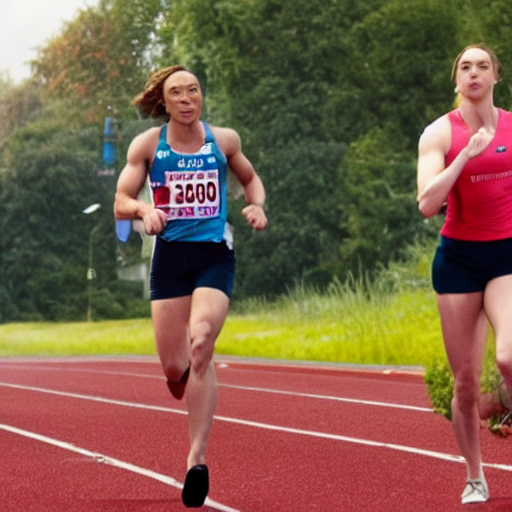Can you describe the expressions and body language of the athletes? The central athlete exhibits a focused and determined expression, with her gaze fixed straight ahead, suggesting she's in a critical moment of competition. Her body language, with powerful strides and arms driving in opposition, indicates she's exerting substantial effort to maintain speed. The athlete in the background appears to clap, a gesture that could signify encouragement or celebration, and her facial expression seems to convey enthusiasm, reflecting the dynamics of the sporting event. 